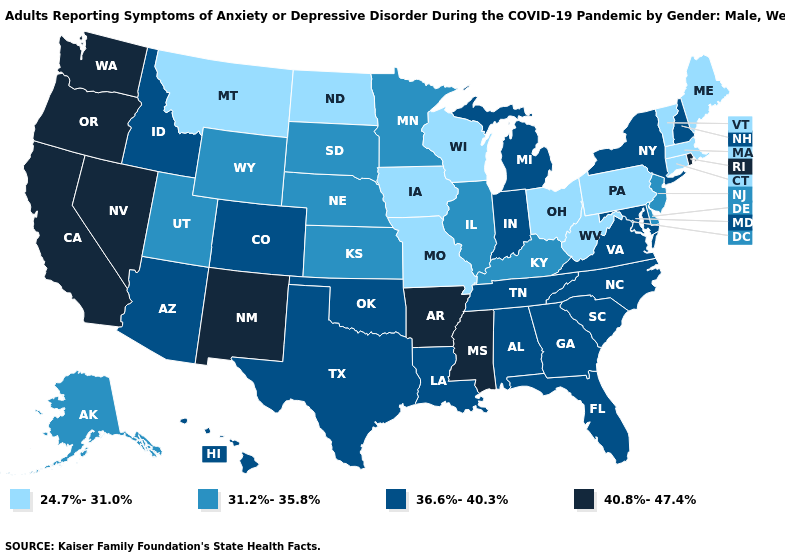Does the first symbol in the legend represent the smallest category?
Quick response, please. Yes. Does the map have missing data?
Concise answer only. No. Among the states that border Alabama , does Georgia have the lowest value?
Answer briefly. Yes. Name the states that have a value in the range 40.8%-47.4%?
Keep it brief. Arkansas, California, Mississippi, Nevada, New Mexico, Oregon, Rhode Island, Washington. Does Washington have a higher value than Arkansas?
Concise answer only. No. Does the map have missing data?
Concise answer only. No. Name the states that have a value in the range 36.6%-40.3%?
Keep it brief. Alabama, Arizona, Colorado, Florida, Georgia, Hawaii, Idaho, Indiana, Louisiana, Maryland, Michigan, New Hampshire, New York, North Carolina, Oklahoma, South Carolina, Tennessee, Texas, Virginia. What is the value of Missouri?
Answer briefly. 24.7%-31.0%. How many symbols are there in the legend?
Be succinct. 4. Name the states that have a value in the range 24.7%-31.0%?
Short answer required. Connecticut, Iowa, Maine, Massachusetts, Missouri, Montana, North Dakota, Ohio, Pennsylvania, Vermont, West Virginia, Wisconsin. Name the states that have a value in the range 36.6%-40.3%?
Short answer required. Alabama, Arizona, Colorado, Florida, Georgia, Hawaii, Idaho, Indiana, Louisiana, Maryland, Michigan, New Hampshire, New York, North Carolina, Oklahoma, South Carolina, Tennessee, Texas, Virginia. Name the states that have a value in the range 40.8%-47.4%?
Write a very short answer. Arkansas, California, Mississippi, Nevada, New Mexico, Oregon, Rhode Island, Washington. Name the states that have a value in the range 36.6%-40.3%?
Give a very brief answer. Alabama, Arizona, Colorado, Florida, Georgia, Hawaii, Idaho, Indiana, Louisiana, Maryland, Michigan, New Hampshire, New York, North Carolina, Oklahoma, South Carolina, Tennessee, Texas, Virginia. 